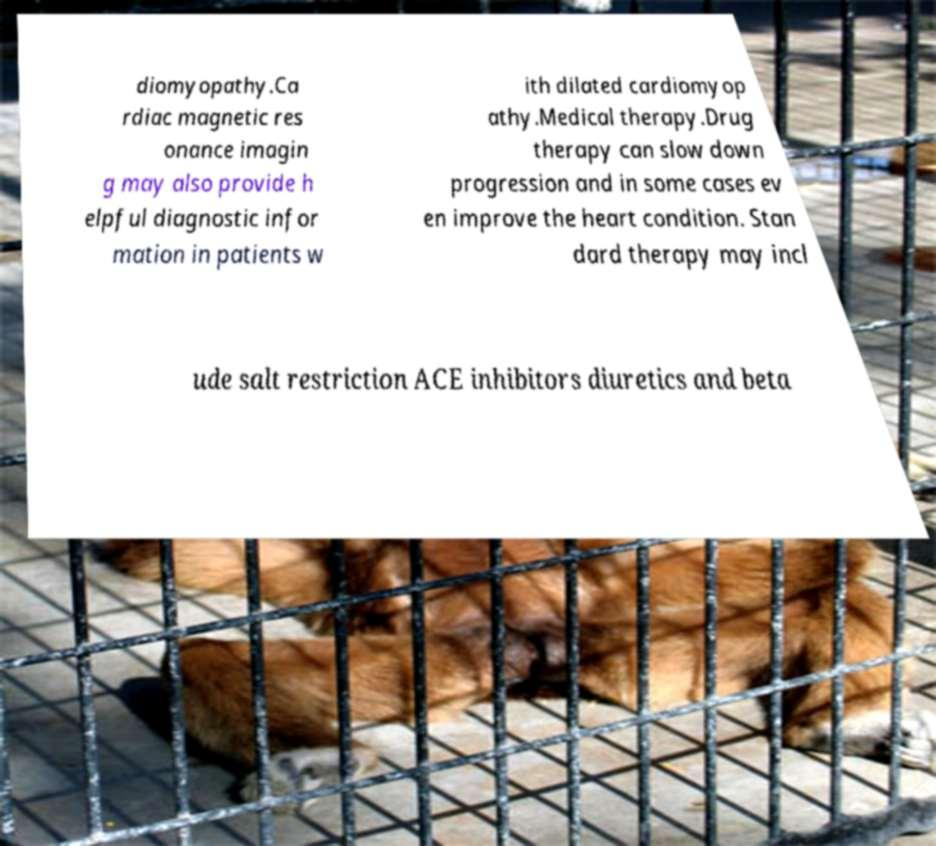Could you assist in decoding the text presented in this image and type it out clearly? diomyopathy.Ca rdiac magnetic res onance imagin g may also provide h elpful diagnostic infor mation in patients w ith dilated cardiomyop athy.Medical therapy.Drug therapy can slow down progression and in some cases ev en improve the heart condition. Stan dard therapy may incl ude salt restriction ACE inhibitors diuretics and beta 